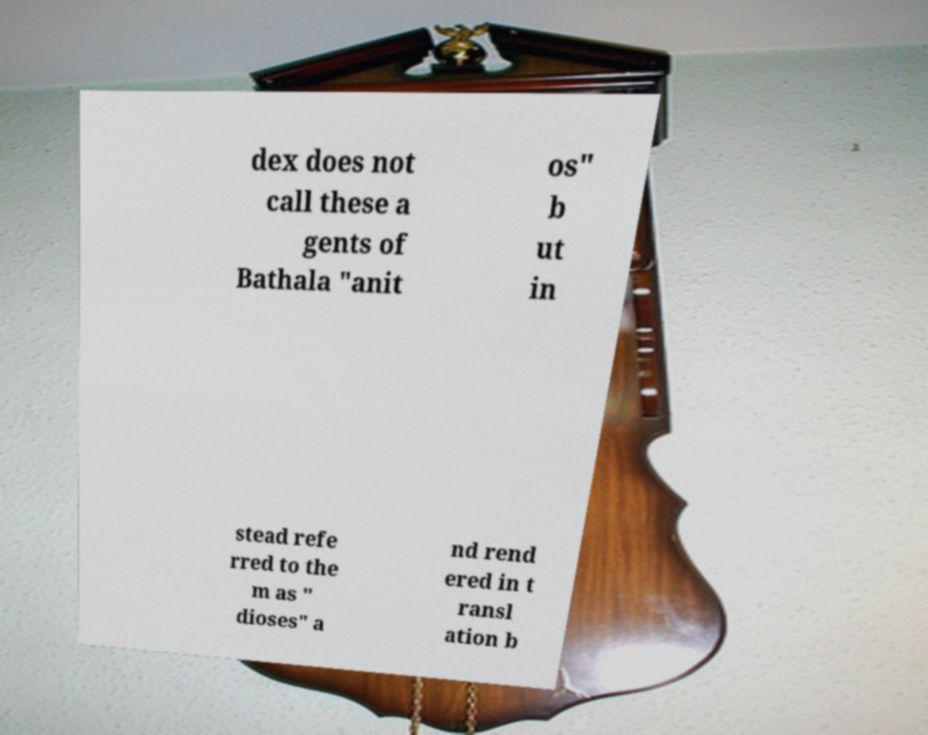For documentation purposes, I need the text within this image transcribed. Could you provide that? dex does not call these a gents of Bathala "anit os" b ut in stead refe rred to the m as " dioses" a nd rend ered in t ransl ation b 